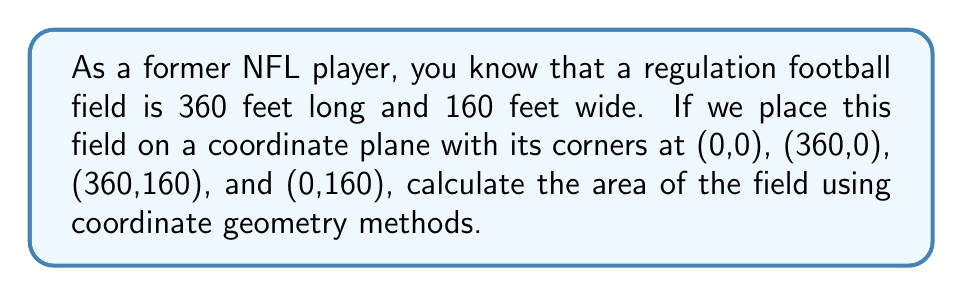Could you help me with this problem? To solve this problem, we can use the shoelace formula (also known as the surveyor's formula) for calculating the area of a polygon given its vertices. The formula is:

$$A = \frac{1}{2}|\sum_{i=1}^{n} (x_i y_{i+1} - x_{i+1} y_i)|$$

Where $(x_i, y_i)$ are the coordinates of the $i$-th vertex, and $(x_{n+1}, y_{n+1}) = (x_1, y_1)$.

Let's apply this to our football field:

1) The vertices are:
   $(x_1, y_1) = (0, 0)$
   $(x_2, y_2) = (360, 0)$
   $(x_3, y_3) = (360, 160)$
   $(x_4, y_4) = (0, 160)$

2) Applying the formula:

   $$\begin{align*}
   A &= \frac{1}{2}|(0 \cdot 0 - 360 \cdot 0) + (360 \cdot 160 - 360 \cdot 160) + (360 \cdot 160 - 0 \cdot 160) + (0 \cdot 0 - 0 \cdot 160)|\\
   &= \frac{1}{2}|(0) + (0) + (57600) + (0)|\\
   &= \frac{1}{2}(57600)\\
   &= 28800
   \end{align*}$$

3) Therefore, the area is 28,800 square feet.

Note: We can verify this result by using the simple length × width formula:
360 feet × 160 feet = 57,600 square feet

The coordinate geometry method gives us half of this value because we're calculating the area of a triangle twice (the diagonal of the rectangle divides it into two equal triangles), and then taking the absolute value.
Answer: The area of the football field is 57,600 square feet. 